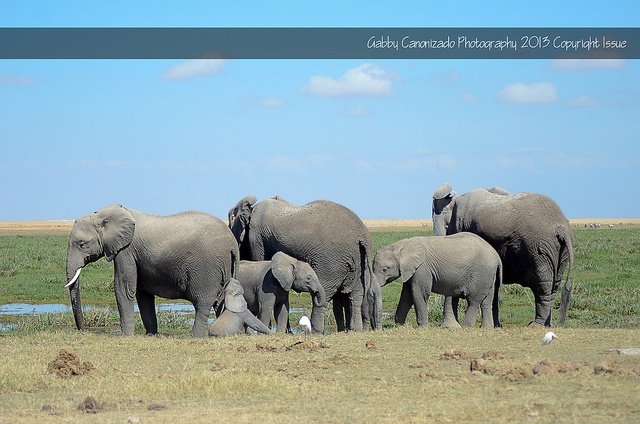Describe the objects in this image and their specific colors. I can see elephant in lightblue, gray, darkgray, and black tones, elephant in lightblue, gray, black, and darkgray tones, elephant in lightblue, gray, darkgray, and black tones, elephant in lightblue, darkgray, gray, and black tones, and elephant in lightblue, gray, darkgray, and black tones in this image. 